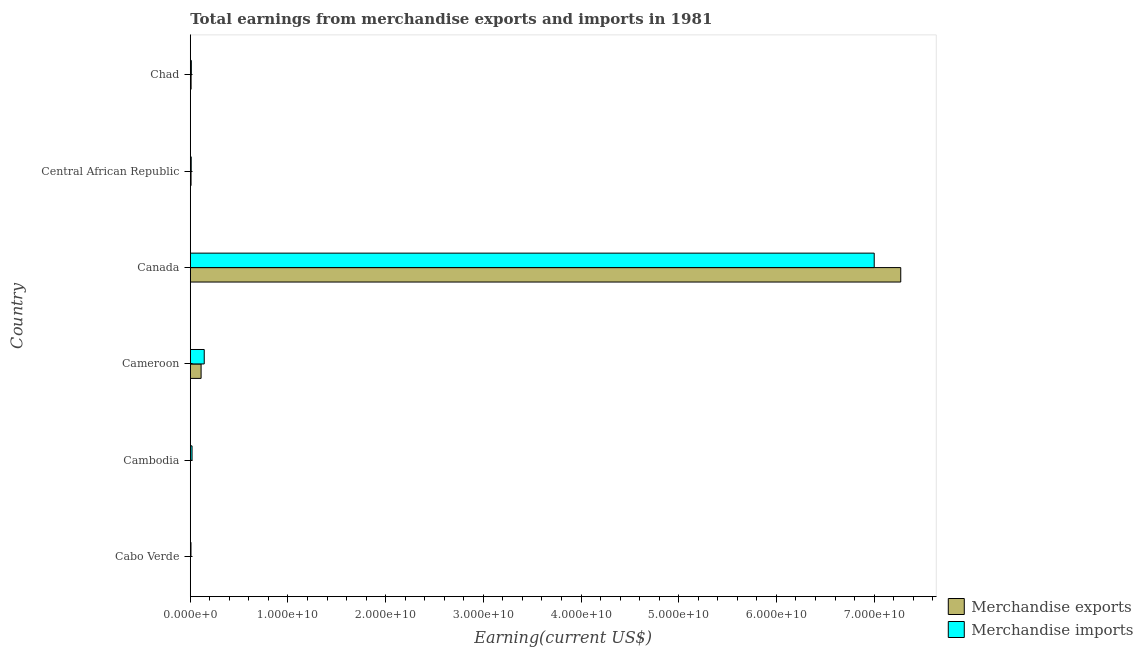Are the number of bars on each tick of the Y-axis equal?
Give a very brief answer. Yes. How many bars are there on the 2nd tick from the top?
Provide a short and direct response. 2. What is the label of the 6th group of bars from the top?
Offer a terse response. Cabo Verde. In how many cases, is the number of bars for a given country not equal to the number of legend labels?
Ensure brevity in your answer.  0. What is the earnings from merchandise exports in Canada?
Your answer should be compact. 7.27e+1. Across all countries, what is the maximum earnings from merchandise exports?
Provide a succinct answer. 7.27e+1. Across all countries, what is the minimum earnings from merchandise exports?
Make the answer very short. 3.00e+06. In which country was the earnings from merchandise exports minimum?
Make the answer very short. Cabo Verde. What is the total earnings from merchandise imports in the graph?
Your answer should be compact. 7.19e+1. What is the difference between the earnings from merchandise imports in Cabo Verde and that in Chad?
Provide a succinct answer. -3.70e+07. What is the difference between the earnings from merchandise exports in Cameroon and the earnings from merchandise imports in Cambodia?
Your answer should be compact. 9.25e+08. What is the average earnings from merchandise imports per country?
Make the answer very short. 1.20e+1. What is the difference between the earnings from merchandise imports and earnings from merchandise exports in Cameroon?
Ensure brevity in your answer.  3.22e+08. In how many countries, is the earnings from merchandise imports greater than 4000000000 US$?
Your response must be concise. 1. Is the earnings from merchandise exports in Cabo Verde less than that in Canada?
Your answer should be compact. Yes. What is the difference between the highest and the second highest earnings from merchandise imports?
Make the answer very short. 6.86e+1. What is the difference between the highest and the lowest earnings from merchandise imports?
Offer a very short reply. 6.99e+1. In how many countries, is the earnings from merchandise imports greater than the average earnings from merchandise imports taken over all countries?
Offer a terse response. 1. What does the 1st bar from the top in Central African Republic represents?
Give a very brief answer. Merchandise imports. Are all the bars in the graph horizontal?
Your answer should be very brief. Yes. Are the values on the major ticks of X-axis written in scientific E-notation?
Your answer should be very brief. Yes. Does the graph contain grids?
Your response must be concise. No. How many legend labels are there?
Provide a succinct answer. 2. What is the title of the graph?
Your answer should be compact. Total earnings from merchandise exports and imports in 1981. What is the label or title of the X-axis?
Ensure brevity in your answer.  Earning(current US$). What is the label or title of the Y-axis?
Keep it short and to the point. Country. What is the Earning(current US$) in Merchandise imports in Cabo Verde?
Your response must be concise. 7.10e+07. What is the Earning(current US$) in Merchandise imports in Cambodia?
Your answer should be very brief. 1.80e+08. What is the Earning(current US$) in Merchandise exports in Cameroon?
Provide a succinct answer. 1.10e+09. What is the Earning(current US$) of Merchandise imports in Cameroon?
Offer a very short reply. 1.43e+09. What is the Earning(current US$) in Merchandise exports in Canada?
Provide a short and direct response. 7.27e+1. What is the Earning(current US$) of Merchandise imports in Canada?
Ensure brevity in your answer.  7.00e+1. What is the Earning(current US$) of Merchandise exports in Central African Republic?
Make the answer very short. 7.90e+07. What is the Earning(current US$) in Merchandise imports in Central African Republic?
Keep it short and to the point. 9.50e+07. What is the Earning(current US$) in Merchandise exports in Chad?
Give a very brief answer. 8.30e+07. What is the Earning(current US$) of Merchandise imports in Chad?
Your answer should be very brief. 1.08e+08. Across all countries, what is the maximum Earning(current US$) of Merchandise exports?
Ensure brevity in your answer.  7.27e+1. Across all countries, what is the maximum Earning(current US$) of Merchandise imports?
Give a very brief answer. 7.00e+1. Across all countries, what is the minimum Earning(current US$) of Merchandise imports?
Offer a very short reply. 7.10e+07. What is the total Earning(current US$) of Merchandise exports in the graph?
Your response must be concise. 7.40e+1. What is the total Earning(current US$) in Merchandise imports in the graph?
Offer a terse response. 7.19e+1. What is the difference between the Earning(current US$) in Merchandise exports in Cabo Verde and that in Cambodia?
Offer a terse response. -7.00e+06. What is the difference between the Earning(current US$) in Merchandise imports in Cabo Verde and that in Cambodia?
Keep it short and to the point. -1.09e+08. What is the difference between the Earning(current US$) in Merchandise exports in Cabo Verde and that in Cameroon?
Offer a terse response. -1.10e+09. What is the difference between the Earning(current US$) in Merchandise imports in Cabo Verde and that in Cameroon?
Provide a succinct answer. -1.36e+09. What is the difference between the Earning(current US$) of Merchandise exports in Cabo Verde and that in Canada?
Provide a succinct answer. -7.27e+1. What is the difference between the Earning(current US$) of Merchandise imports in Cabo Verde and that in Canada?
Your answer should be compact. -6.99e+1. What is the difference between the Earning(current US$) of Merchandise exports in Cabo Verde and that in Central African Republic?
Offer a terse response. -7.60e+07. What is the difference between the Earning(current US$) of Merchandise imports in Cabo Verde and that in Central African Republic?
Give a very brief answer. -2.40e+07. What is the difference between the Earning(current US$) of Merchandise exports in Cabo Verde and that in Chad?
Keep it short and to the point. -8.00e+07. What is the difference between the Earning(current US$) in Merchandise imports in Cabo Verde and that in Chad?
Offer a very short reply. -3.70e+07. What is the difference between the Earning(current US$) of Merchandise exports in Cambodia and that in Cameroon?
Offer a very short reply. -1.10e+09. What is the difference between the Earning(current US$) of Merchandise imports in Cambodia and that in Cameroon?
Ensure brevity in your answer.  -1.25e+09. What is the difference between the Earning(current US$) of Merchandise exports in Cambodia and that in Canada?
Offer a terse response. -7.27e+1. What is the difference between the Earning(current US$) in Merchandise imports in Cambodia and that in Canada?
Provide a succinct answer. -6.98e+1. What is the difference between the Earning(current US$) in Merchandise exports in Cambodia and that in Central African Republic?
Give a very brief answer. -6.90e+07. What is the difference between the Earning(current US$) in Merchandise imports in Cambodia and that in Central African Republic?
Your response must be concise. 8.50e+07. What is the difference between the Earning(current US$) of Merchandise exports in Cambodia and that in Chad?
Provide a short and direct response. -7.30e+07. What is the difference between the Earning(current US$) of Merchandise imports in Cambodia and that in Chad?
Offer a terse response. 7.20e+07. What is the difference between the Earning(current US$) in Merchandise exports in Cameroon and that in Canada?
Your answer should be very brief. -7.16e+1. What is the difference between the Earning(current US$) in Merchandise imports in Cameroon and that in Canada?
Offer a terse response. -6.86e+1. What is the difference between the Earning(current US$) of Merchandise exports in Cameroon and that in Central African Republic?
Make the answer very short. 1.03e+09. What is the difference between the Earning(current US$) of Merchandise imports in Cameroon and that in Central African Republic?
Provide a succinct answer. 1.33e+09. What is the difference between the Earning(current US$) of Merchandise exports in Cameroon and that in Chad?
Provide a short and direct response. 1.02e+09. What is the difference between the Earning(current US$) in Merchandise imports in Cameroon and that in Chad?
Make the answer very short. 1.32e+09. What is the difference between the Earning(current US$) in Merchandise exports in Canada and that in Central African Republic?
Ensure brevity in your answer.  7.26e+1. What is the difference between the Earning(current US$) in Merchandise imports in Canada and that in Central African Republic?
Keep it short and to the point. 6.99e+1. What is the difference between the Earning(current US$) in Merchandise exports in Canada and that in Chad?
Keep it short and to the point. 7.26e+1. What is the difference between the Earning(current US$) in Merchandise imports in Canada and that in Chad?
Keep it short and to the point. 6.99e+1. What is the difference between the Earning(current US$) of Merchandise exports in Central African Republic and that in Chad?
Offer a terse response. -4.00e+06. What is the difference between the Earning(current US$) in Merchandise imports in Central African Republic and that in Chad?
Keep it short and to the point. -1.30e+07. What is the difference between the Earning(current US$) of Merchandise exports in Cabo Verde and the Earning(current US$) of Merchandise imports in Cambodia?
Offer a very short reply. -1.77e+08. What is the difference between the Earning(current US$) in Merchandise exports in Cabo Verde and the Earning(current US$) in Merchandise imports in Cameroon?
Offer a terse response. -1.42e+09. What is the difference between the Earning(current US$) of Merchandise exports in Cabo Verde and the Earning(current US$) of Merchandise imports in Canada?
Ensure brevity in your answer.  -7.00e+1. What is the difference between the Earning(current US$) in Merchandise exports in Cabo Verde and the Earning(current US$) in Merchandise imports in Central African Republic?
Make the answer very short. -9.20e+07. What is the difference between the Earning(current US$) in Merchandise exports in Cabo Verde and the Earning(current US$) in Merchandise imports in Chad?
Offer a very short reply. -1.05e+08. What is the difference between the Earning(current US$) in Merchandise exports in Cambodia and the Earning(current US$) in Merchandise imports in Cameroon?
Your answer should be very brief. -1.42e+09. What is the difference between the Earning(current US$) in Merchandise exports in Cambodia and the Earning(current US$) in Merchandise imports in Canada?
Keep it short and to the point. -7.00e+1. What is the difference between the Earning(current US$) in Merchandise exports in Cambodia and the Earning(current US$) in Merchandise imports in Central African Republic?
Your answer should be very brief. -8.50e+07. What is the difference between the Earning(current US$) in Merchandise exports in Cambodia and the Earning(current US$) in Merchandise imports in Chad?
Ensure brevity in your answer.  -9.80e+07. What is the difference between the Earning(current US$) in Merchandise exports in Cameroon and the Earning(current US$) in Merchandise imports in Canada?
Give a very brief answer. -6.89e+1. What is the difference between the Earning(current US$) of Merchandise exports in Cameroon and the Earning(current US$) of Merchandise imports in Central African Republic?
Keep it short and to the point. 1.01e+09. What is the difference between the Earning(current US$) in Merchandise exports in Cameroon and the Earning(current US$) in Merchandise imports in Chad?
Your response must be concise. 9.97e+08. What is the difference between the Earning(current US$) of Merchandise exports in Canada and the Earning(current US$) of Merchandise imports in Central African Republic?
Provide a short and direct response. 7.26e+1. What is the difference between the Earning(current US$) of Merchandise exports in Canada and the Earning(current US$) of Merchandise imports in Chad?
Provide a short and direct response. 7.26e+1. What is the difference between the Earning(current US$) of Merchandise exports in Central African Republic and the Earning(current US$) of Merchandise imports in Chad?
Provide a succinct answer. -2.90e+07. What is the average Earning(current US$) of Merchandise exports per country?
Your answer should be very brief. 1.23e+1. What is the average Earning(current US$) in Merchandise imports per country?
Your response must be concise. 1.20e+1. What is the difference between the Earning(current US$) of Merchandise exports and Earning(current US$) of Merchandise imports in Cabo Verde?
Offer a terse response. -6.80e+07. What is the difference between the Earning(current US$) of Merchandise exports and Earning(current US$) of Merchandise imports in Cambodia?
Your answer should be very brief. -1.70e+08. What is the difference between the Earning(current US$) of Merchandise exports and Earning(current US$) of Merchandise imports in Cameroon?
Provide a short and direct response. -3.22e+08. What is the difference between the Earning(current US$) in Merchandise exports and Earning(current US$) in Merchandise imports in Canada?
Your answer should be very brief. 2.72e+09. What is the difference between the Earning(current US$) in Merchandise exports and Earning(current US$) in Merchandise imports in Central African Republic?
Give a very brief answer. -1.60e+07. What is the difference between the Earning(current US$) in Merchandise exports and Earning(current US$) in Merchandise imports in Chad?
Make the answer very short. -2.50e+07. What is the ratio of the Earning(current US$) in Merchandise exports in Cabo Verde to that in Cambodia?
Keep it short and to the point. 0.3. What is the ratio of the Earning(current US$) in Merchandise imports in Cabo Verde to that in Cambodia?
Provide a short and direct response. 0.39. What is the ratio of the Earning(current US$) in Merchandise exports in Cabo Verde to that in Cameroon?
Offer a very short reply. 0. What is the ratio of the Earning(current US$) of Merchandise imports in Cabo Verde to that in Cameroon?
Offer a terse response. 0.05. What is the ratio of the Earning(current US$) in Merchandise exports in Cabo Verde to that in Canada?
Your response must be concise. 0. What is the ratio of the Earning(current US$) in Merchandise imports in Cabo Verde to that in Canada?
Offer a very short reply. 0. What is the ratio of the Earning(current US$) of Merchandise exports in Cabo Verde to that in Central African Republic?
Your answer should be compact. 0.04. What is the ratio of the Earning(current US$) of Merchandise imports in Cabo Verde to that in Central African Republic?
Make the answer very short. 0.75. What is the ratio of the Earning(current US$) in Merchandise exports in Cabo Verde to that in Chad?
Offer a terse response. 0.04. What is the ratio of the Earning(current US$) of Merchandise imports in Cabo Verde to that in Chad?
Ensure brevity in your answer.  0.66. What is the ratio of the Earning(current US$) of Merchandise exports in Cambodia to that in Cameroon?
Give a very brief answer. 0.01. What is the ratio of the Earning(current US$) in Merchandise imports in Cambodia to that in Cameroon?
Ensure brevity in your answer.  0.13. What is the ratio of the Earning(current US$) of Merchandise imports in Cambodia to that in Canada?
Provide a short and direct response. 0. What is the ratio of the Earning(current US$) in Merchandise exports in Cambodia to that in Central African Republic?
Give a very brief answer. 0.13. What is the ratio of the Earning(current US$) of Merchandise imports in Cambodia to that in Central African Republic?
Ensure brevity in your answer.  1.89. What is the ratio of the Earning(current US$) in Merchandise exports in Cambodia to that in Chad?
Your answer should be compact. 0.12. What is the ratio of the Earning(current US$) of Merchandise imports in Cambodia to that in Chad?
Give a very brief answer. 1.67. What is the ratio of the Earning(current US$) of Merchandise exports in Cameroon to that in Canada?
Your answer should be very brief. 0.02. What is the ratio of the Earning(current US$) in Merchandise imports in Cameroon to that in Canada?
Your response must be concise. 0.02. What is the ratio of the Earning(current US$) of Merchandise exports in Cameroon to that in Central African Republic?
Your answer should be very brief. 13.99. What is the ratio of the Earning(current US$) of Merchandise imports in Cameroon to that in Central African Republic?
Your answer should be very brief. 15.02. What is the ratio of the Earning(current US$) of Merchandise exports in Cameroon to that in Chad?
Ensure brevity in your answer.  13.31. What is the ratio of the Earning(current US$) of Merchandise imports in Cameroon to that in Chad?
Provide a short and direct response. 13.21. What is the ratio of the Earning(current US$) of Merchandise exports in Canada to that in Central African Republic?
Offer a terse response. 920.58. What is the ratio of the Earning(current US$) of Merchandise imports in Canada to that in Central African Republic?
Ensure brevity in your answer.  736.95. What is the ratio of the Earning(current US$) of Merchandise exports in Canada to that in Chad?
Offer a very short reply. 876.22. What is the ratio of the Earning(current US$) of Merchandise imports in Canada to that in Chad?
Make the answer very short. 648.24. What is the ratio of the Earning(current US$) in Merchandise exports in Central African Republic to that in Chad?
Give a very brief answer. 0.95. What is the ratio of the Earning(current US$) in Merchandise imports in Central African Republic to that in Chad?
Provide a succinct answer. 0.88. What is the difference between the highest and the second highest Earning(current US$) of Merchandise exports?
Your response must be concise. 7.16e+1. What is the difference between the highest and the second highest Earning(current US$) of Merchandise imports?
Provide a short and direct response. 6.86e+1. What is the difference between the highest and the lowest Earning(current US$) in Merchandise exports?
Your answer should be compact. 7.27e+1. What is the difference between the highest and the lowest Earning(current US$) of Merchandise imports?
Provide a short and direct response. 6.99e+1. 